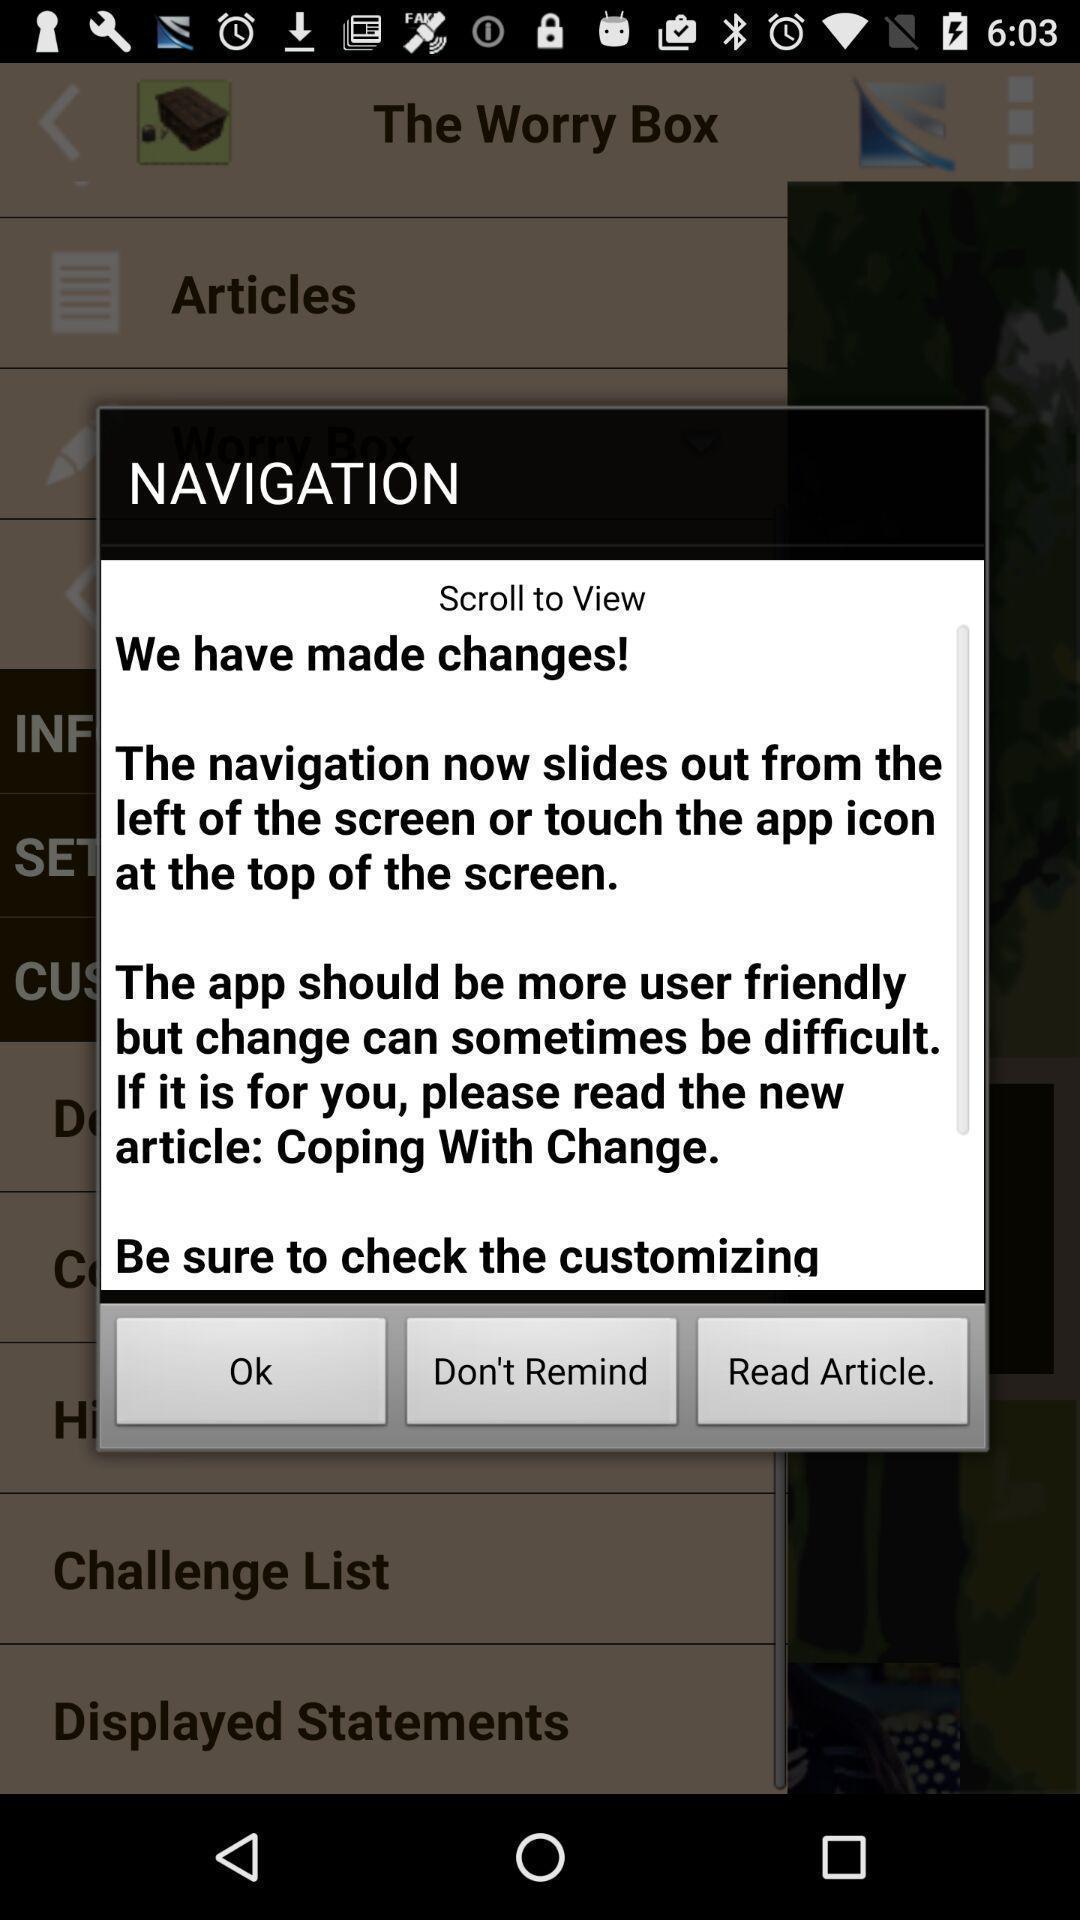Summarize the main components in this picture. Pop-up to choose an option. 